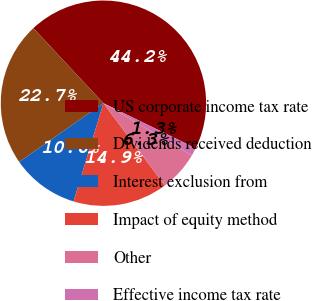Convert chart. <chart><loc_0><loc_0><loc_500><loc_500><pie_chart><fcel>US corporate income tax rate<fcel>Dividends received deduction<fcel>Interest exclusion from<fcel>Impact of equity method<fcel>Other<fcel>Effective income tax rate<nl><fcel>44.19%<fcel>22.73%<fcel>10.61%<fcel>14.9%<fcel>6.31%<fcel>1.26%<nl></chart> 